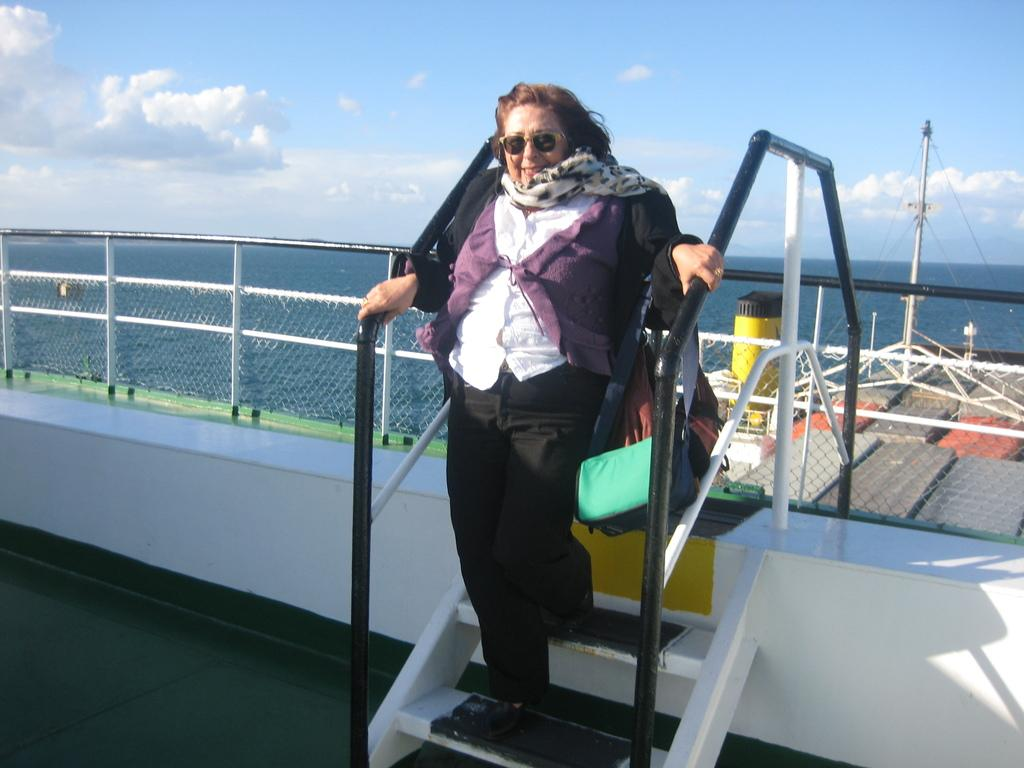What is the person in the image doing? The person is standing on a staircase in the image. What can be seen near the person in the image? There is a fence in the image. What is visible in the background of the image? The sky, clouds, and water are visible in the background of the image. What is the person attempting to profit from in the image? There is no indication in the image that the person is attempting to profit from anything. 